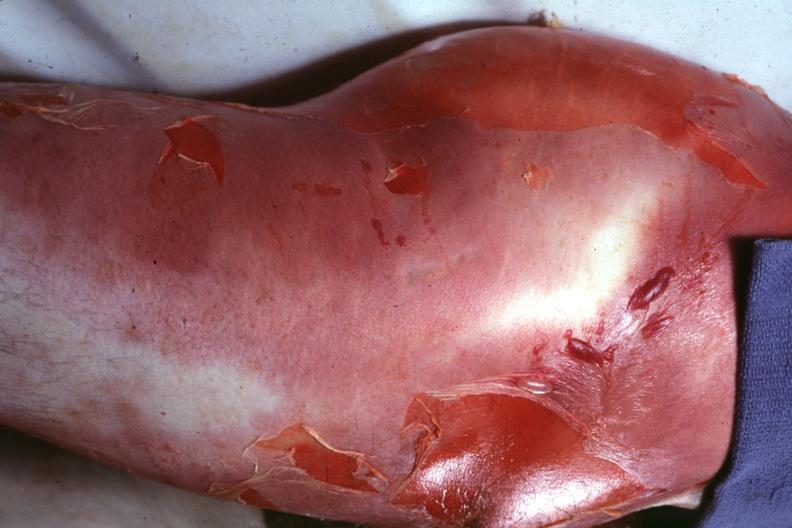what does this image show?
Answer the question using a single word or phrase. Buttock and thigh with severe cellulitis and desquamation caused by a clostridium 